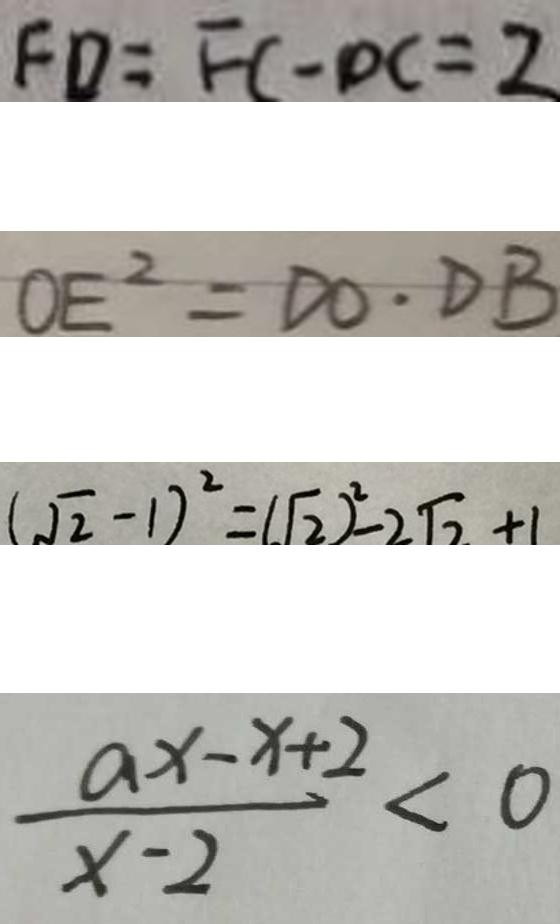Convert formula to latex. <formula><loc_0><loc_0><loc_500><loc_500>F D = F C - D C = 2 
 O E ^ { 2 } = D O \cdot D B 
 ( \sqrt { 2 } - 1 ) ^ { 2 } = ( \sqrt { 2 } ) ^ { 2 } - 2 \sqrt { 2 } + 1 
 \frac { a x - x + 2 } { x - 2 } < 0</formula> 